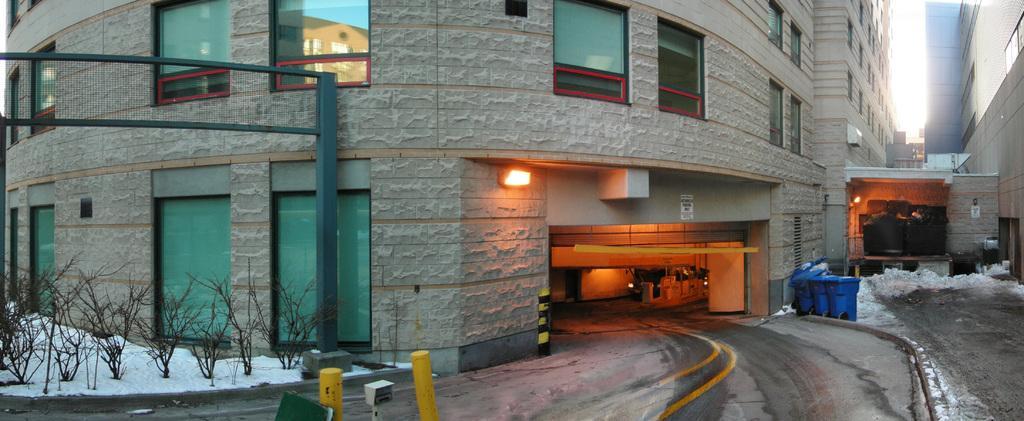Please provide a concise description of this image. In this image there is a building as we can see in middle of this image. There are some plants on the bottom left side of this image and there are some objects kept on the right side of this image, and the objects are in blue color. There is one light in middle of this image. 